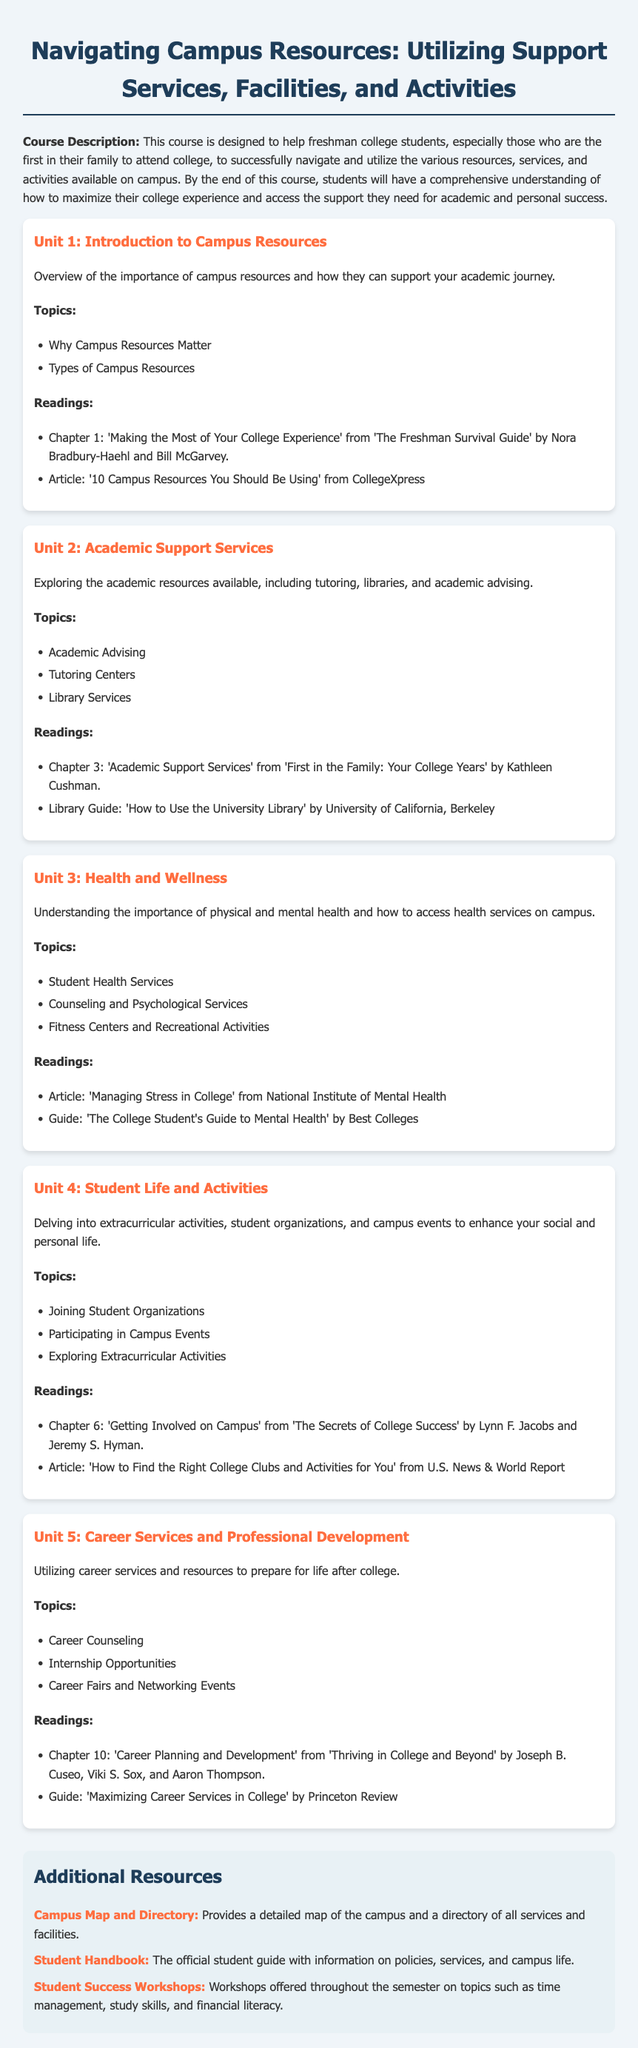What is the course designed to help students with? The course is designed to help freshman college students successfully navigate and utilize the various resources, services, and activities available on campus.
Answer: navigating campus resources What is the first topic covered in Unit 1? The first topic in Unit 1 discusses the importance of campus resources.
Answer: Why Campus Resources Matter What reading is included in Unit 3? Unit 3 includes an article titled "Managing Stress in College" from the National Institute of Mental Health.
Answer: Managing Stress in College How many units are in the syllabus? The syllabus contains five distinct units.
Answer: five Which chapter is referenced in Unit 5 for career planning? Chapter 10, titled "Career Planning and Development," is referenced in Unit 5.
Answer: Chapter 10: 'Career Planning and Development' What type of services are explored in Unit 2? Unit 2 explores academic support services available on campus.
Answer: academic support services What is offered throughout the semester according to the additional resources? Student Success Workshops are offered throughout the semester on various topics.
Answer: Student Success Workshops Which reading in Unit 4 focuses on campus involvement? The reading in Unit 4 that focuses on campus involvement is from "The Secrets of College Success."
Answer: The Secrets of College Success 